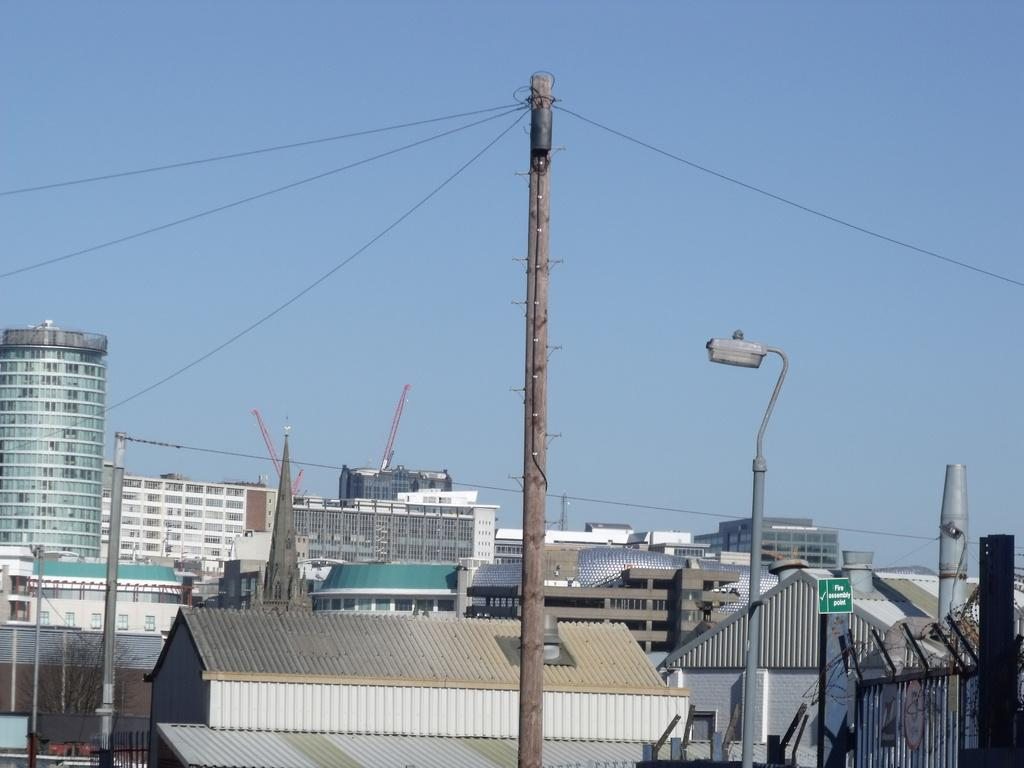What type of structures can be seen in the image? There are buildings in the image. What else is present in the image besides the buildings? Current poles with wires, a sign board, and a fence to the railing are visible in the image. What can be seen in the background of the image? The sky is visible in the background of the image. What type of ornament is hanging from the jeans in the image? There are no jeans or ornaments present in the image. What type of journey is depicted in the image? The image does not depict a journey; it shows buildings, current poles with wires, a sign board, a fence to the railing, and the sky. 